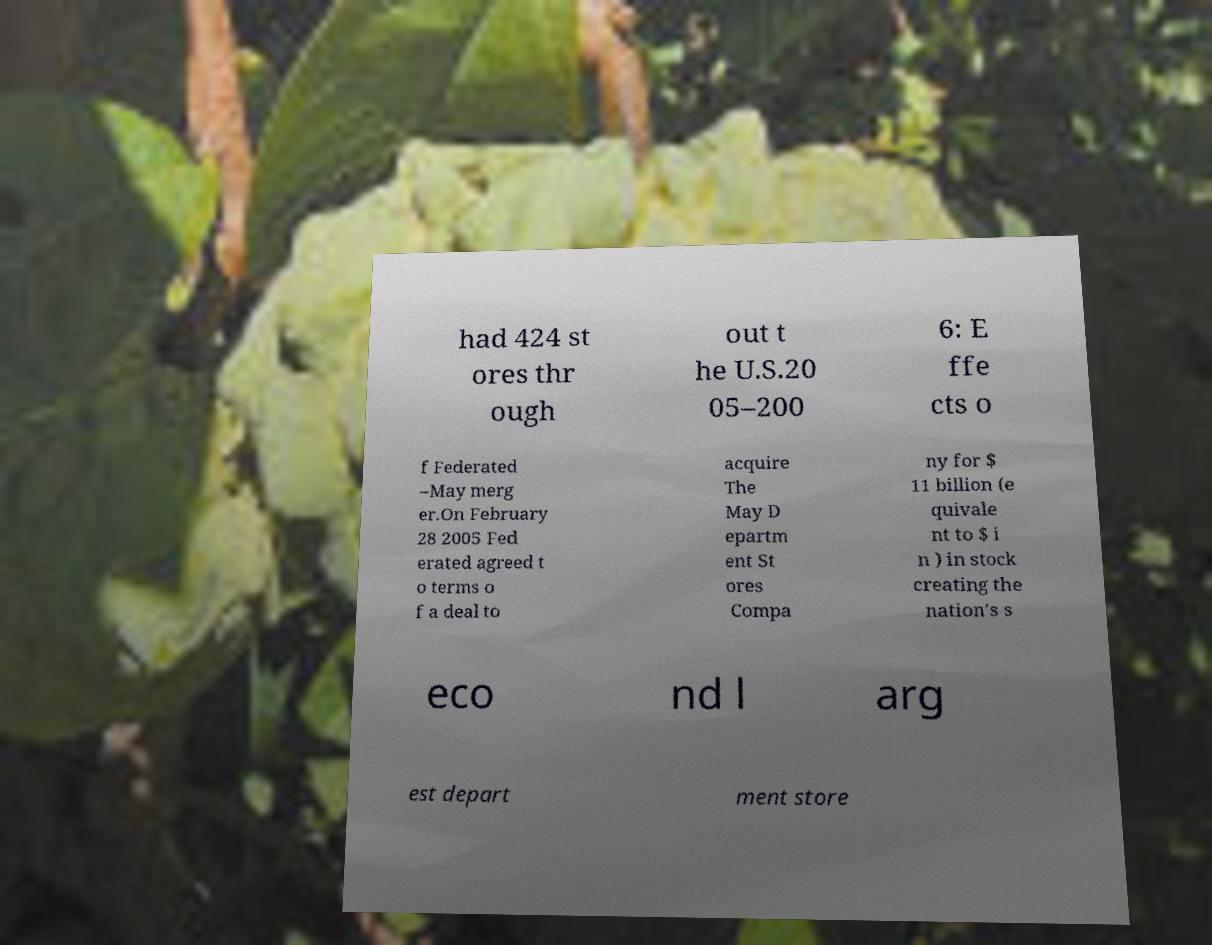Could you extract and type out the text from this image? had 424 st ores thr ough out t he U.S.20 05–200 6: E ffe cts o f Federated –May merg er.On February 28 2005 Fed erated agreed t o terms o f a deal to acquire The May D epartm ent St ores Compa ny for $ 11 billion (e quivale nt to $ i n ) in stock creating the nation's s eco nd l arg est depart ment store 